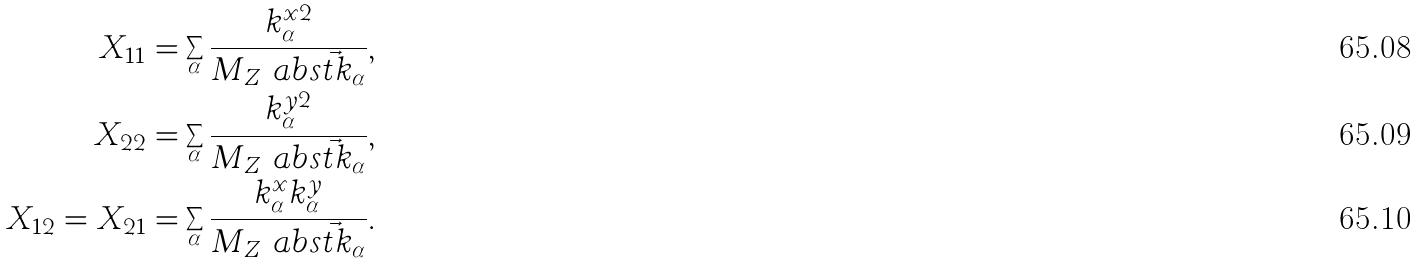Convert formula to latex. <formula><loc_0><loc_0><loc_500><loc_500>X _ { 1 1 } & = \sum _ { \alpha } \frac { k _ { \alpha } ^ { x 2 } } { M _ { Z } \ a b s { \vec { t } { k } _ { \alpha } } } , \\ X _ { 2 2 } & = \sum _ { \alpha } \frac { k _ { \alpha } ^ { y 2 } } { M _ { Z } \ a b s { \vec { t } { k } _ { \alpha } } } , \\ X _ { 1 2 } = X _ { 2 1 } & = \sum _ { \alpha } \frac { k _ { \alpha } ^ { x } k _ { \alpha } ^ { y } } { M _ { Z } \ a b s { \vec { t } { k } _ { \alpha } } } .</formula> 